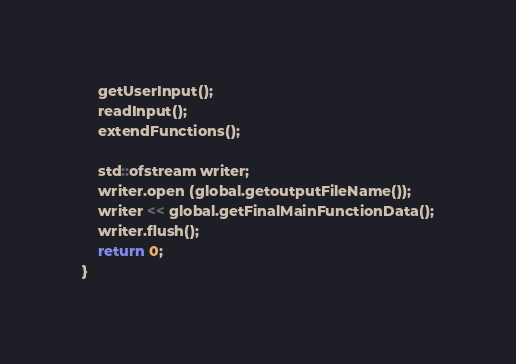<code> <loc_0><loc_0><loc_500><loc_500><_C++_>    getUserInput();
    readInput();
    extendFunctions();
    
    std::ofstream writer;
    writer.open (global.getoutputFileName());
    writer << global.getFinalMainFunctionData();
    writer.flush();
    return 0;
}
</code> 